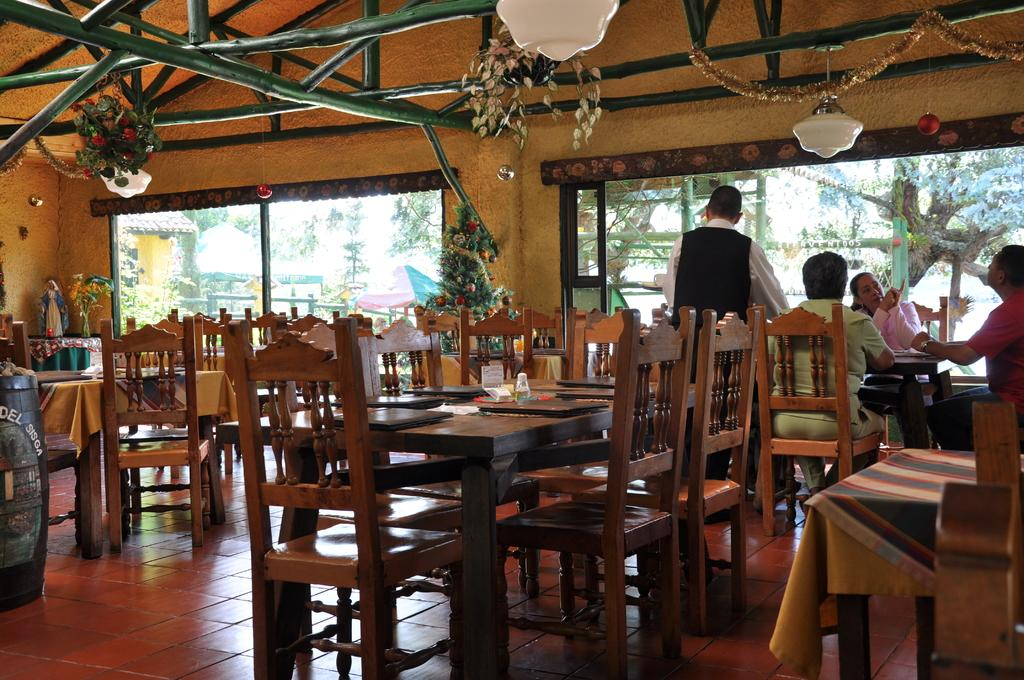What type of furniture is present in the image? There are chairs and tables in the image. How many people are sitting on the chairs? There are seven persons sitting on chairs. What other objects can be seen in the image? There is a plant and a window in the image. What type of yoke is being used by the persons in the image? There is no yoke present in the image; it features chairs, tables, a plant, and a window. Can you see any pipes in the image? There are no pipes visible in the image. 